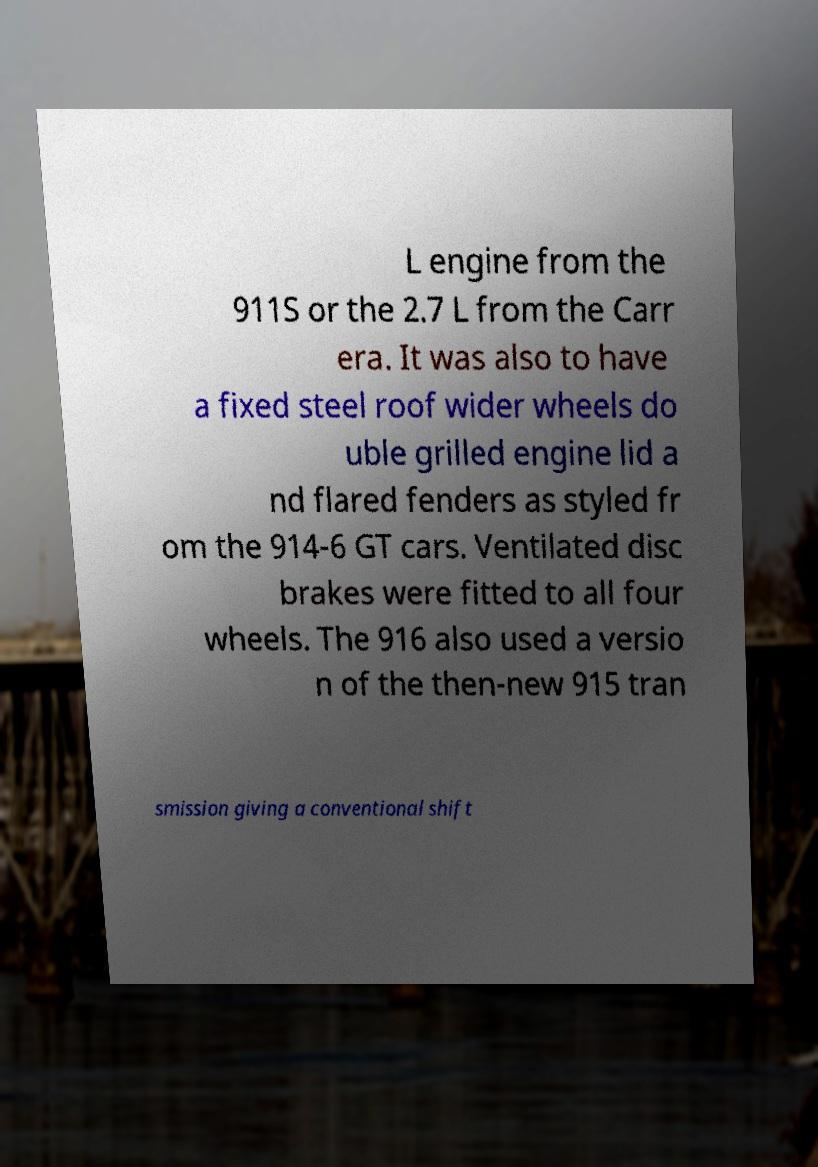Can you accurately transcribe the text from the provided image for me? L engine from the 911S or the 2.7 L from the Carr era. It was also to have a fixed steel roof wider wheels do uble grilled engine lid a nd flared fenders as styled fr om the 914-6 GT cars. Ventilated disc brakes were fitted to all four wheels. The 916 also used a versio n of the then-new 915 tran smission giving a conventional shift 